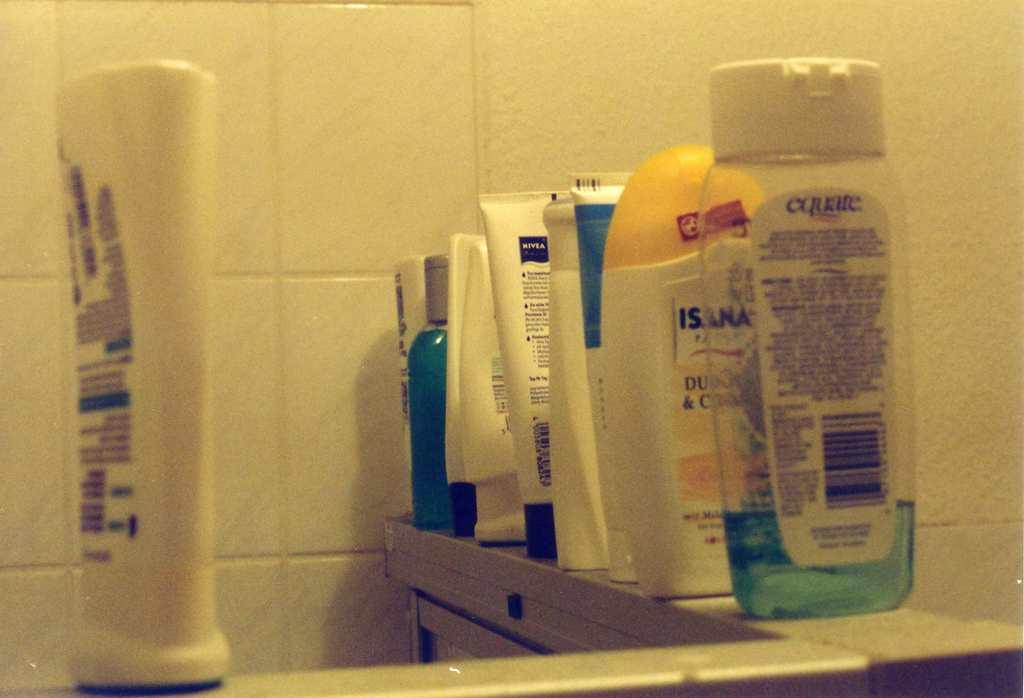<image>
Create a compact narrative representing the image presented. Bottle of Curate in front of a bottle of Isana. 